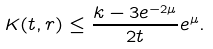<formula> <loc_0><loc_0><loc_500><loc_500>K ( t , r ) \leq \frac { k - 3 e ^ { - 2 \mu } } { 2 t } e ^ { \mu } .</formula> 